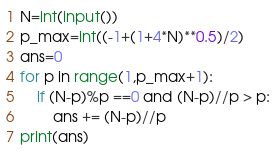Convert code to text. <code><loc_0><loc_0><loc_500><loc_500><_Python_>N=int(input())
p_max=int((-1+(1+4*N)**0.5)/2)
ans=0
for p in range(1,p_max+1):
    if (N-p)%p ==0 and (N-p)//p > p:
        ans += (N-p)//p
print(ans)
</code> 